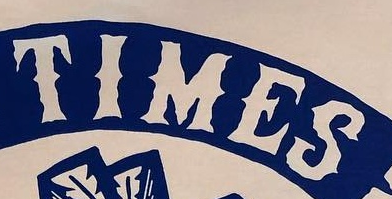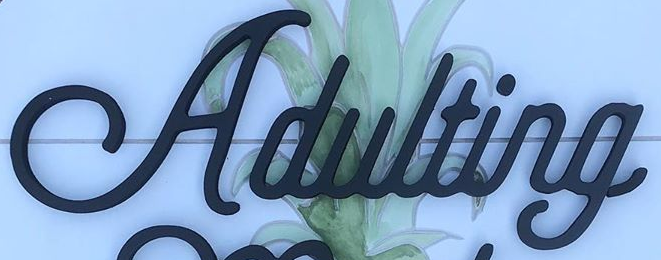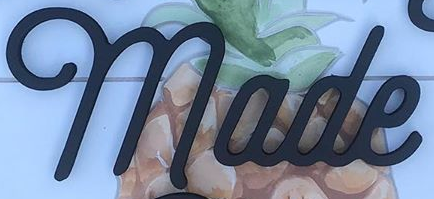Read the text from these images in sequence, separated by a semicolon. TIMES; Adulting; made 